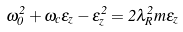<formula> <loc_0><loc_0><loc_500><loc_500>\omega _ { 0 } ^ { 2 } + \omega _ { c } \epsilon _ { z } - \epsilon _ { z } ^ { 2 } = 2 \lambda _ { R } ^ { 2 } m \epsilon _ { z }</formula> 